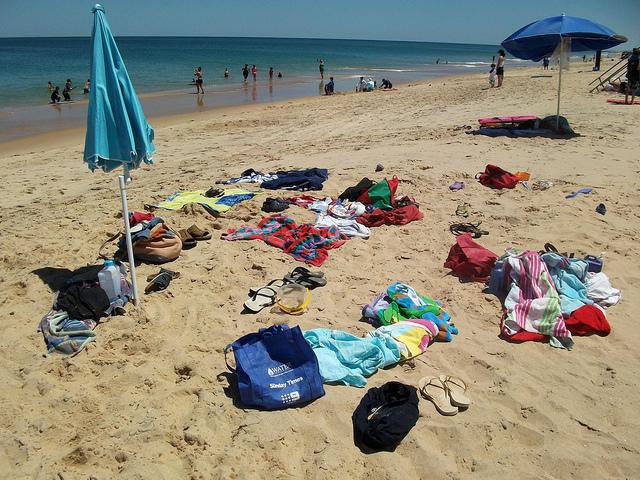Will the clothes get dirty?
Concise answer only. Yes. Why would people need a towel here?
Be succinct. Beach. Is this a beach?
Short answer required. Yes. 